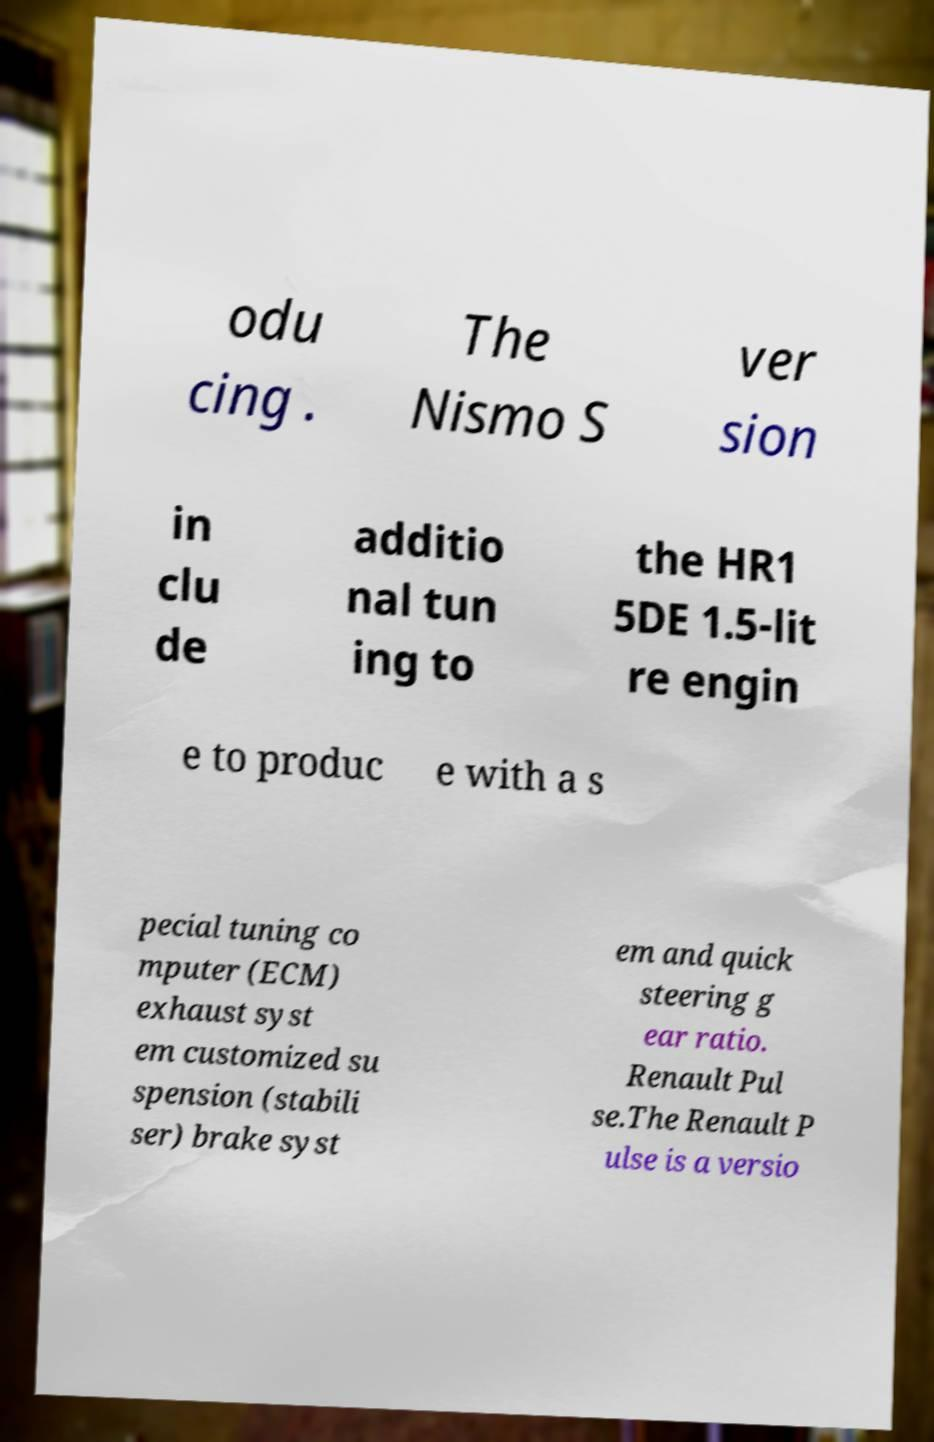Can you accurately transcribe the text from the provided image for me? odu cing . The Nismo S ver sion in clu de additio nal tun ing to the HR1 5DE 1.5-lit re engin e to produc e with a s pecial tuning co mputer (ECM) exhaust syst em customized su spension (stabili ser) brake syst em and quick steering g ear ratio. Renault Pul se.The Renault P ulse is a versio 